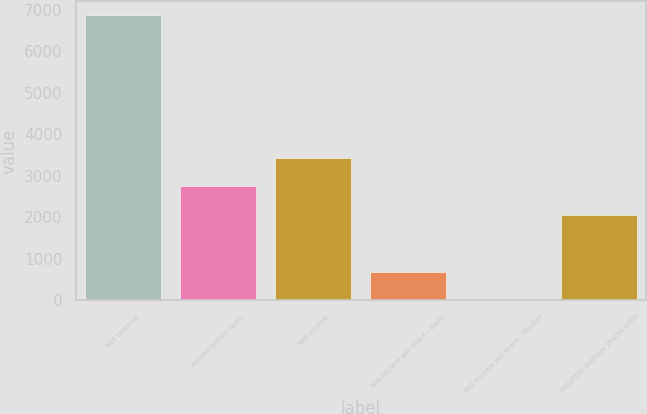Convert chart to OTSL. <chart><loc_0><loc_0><loc_500><loc_500><bar_chart><fcel>Net revenue<fcel>Income before taxes<fcel>Net income<fcel>Net income per share - Basic<fcel>Net income per share - Diluted<fcel>Weighted average shares used<nl><fcel>6858<fcel>2745.15<fcel>3430.62<fcel>688.74<fcel>3.27<fcel>2059.68<nl></chart> 